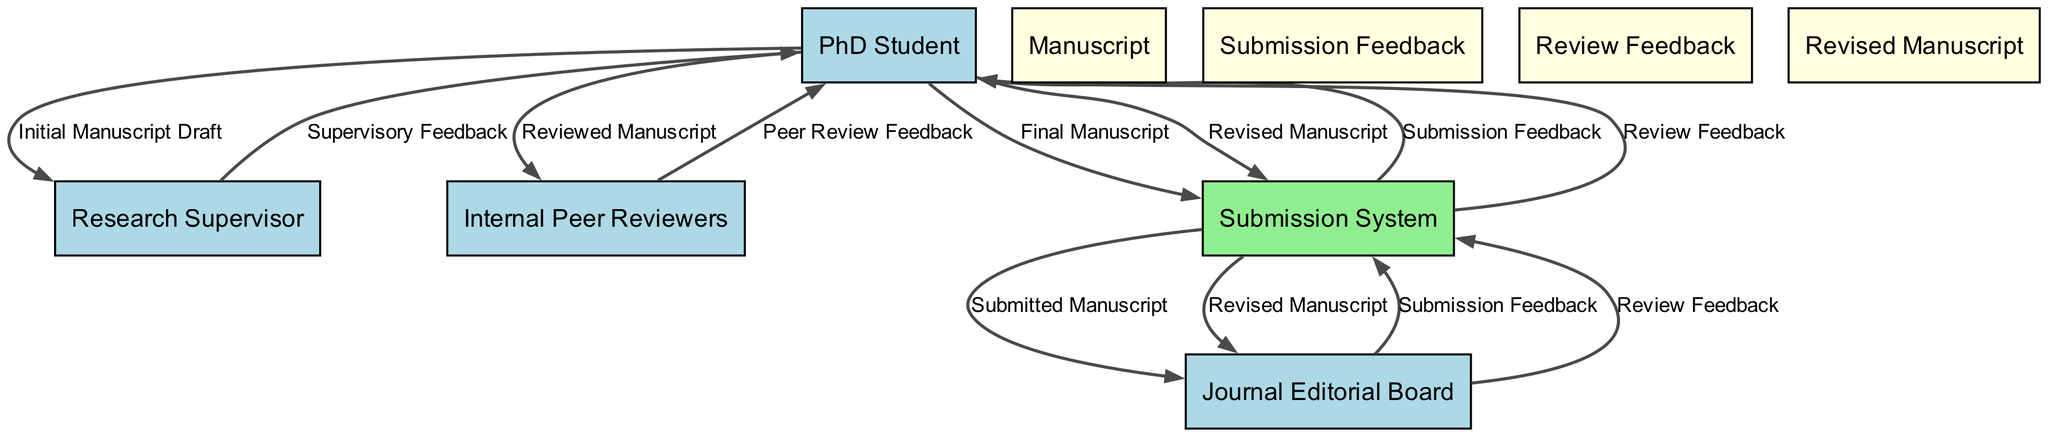What is the first input from the PhD Student? The first input from the PhD Student is an "Initial Manuscript Draft." This can be seen in the flow from the "PhD Student" to the "Research Supervisor" in the diagram.
Answer: Initial Manuscript Draft How many data stores are present in the diagram? There are four data stores in the diagram: "Manuscript," "Submission Feedback," "Review Feedback," and "Revised Manuscript." This can be counted directly from the nodes labeled as data stores.
Answer: 4 Which external entity provides feedback after the manuscript is reviewed? The "Internal Peer Reviewers" provide feedback to the "PhD Student" after reviewing the manuscript. This relationship is clearly indicated in the flow from "Internal Peer Reviewers" to "PhD Student."
Answer: Internal Peer Reviewers What type of data flows from the Submission System to the PhD Student? The data flows from the Submission System to the PhD Student are both "Submission Feedback" and "Review Feedback." This can be confirmed by looking at the two edges leading from the "Submission System" to the "PhD Student."
Answer: Submission Feedback, Review Feedback Which external entity is involved in the submission of the manuscript? The "Journal Editorial Board" is involved in the submission of the manuscript, as indicated by the flow going from the "Submission System" to the "Journal Editorial Board."
Answer: Journal Editorial Board What is the last step taken by the PhD Student in the workflow? The last step taken by the PhD Student is submitting a "Revised Manuscript" back to the Submission System. This final flow is depicted clearly in the diagram.
Answer: Revised Manuscript How many edges are directed toward the Submission System? There are five edges directed toward the Submission System. This can be counted by examining each flow line that ends at the Submission System from other entities.
Answer: 5 What feedback does the Journal Editorial Board provide to the Submission System? The Journal Editorial Board provides "Review Feedback" to the Submission System. This is shown in the flow from "Journal Editorial Board" to "Submission System."
Answer: Review Feedback How does the PhD Student receive feedback from the Research Supervisor? The PhD Student receives "Supervisory Feedback" from the Research Supervisor. This feedback is directly flowing back to the PhD Student from the Research Supervisor.
Answer: Supervisory Feedback 